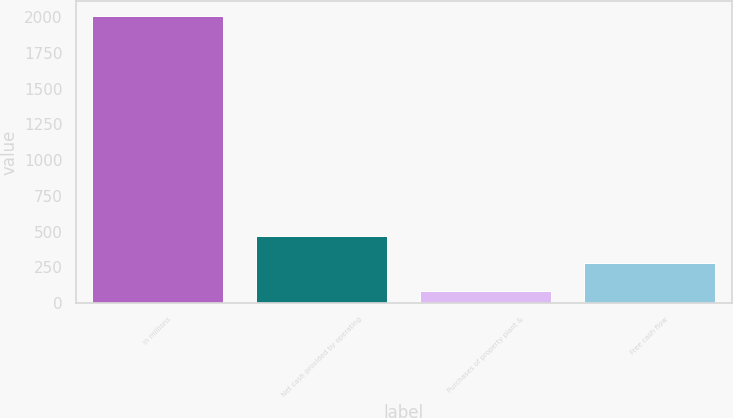Convert chart to OTSL. <chart><loc_0><loc_0><loc_500><loc_500><bar_chart><fcel>in millions<fcel>Net cash provided by operating<fcel>Purchases of property plant &<fcel>Free cash flow<nl><fcel>2010<fcel>471.04<fcel>86.3<fcel>278.67<nl></chart> 